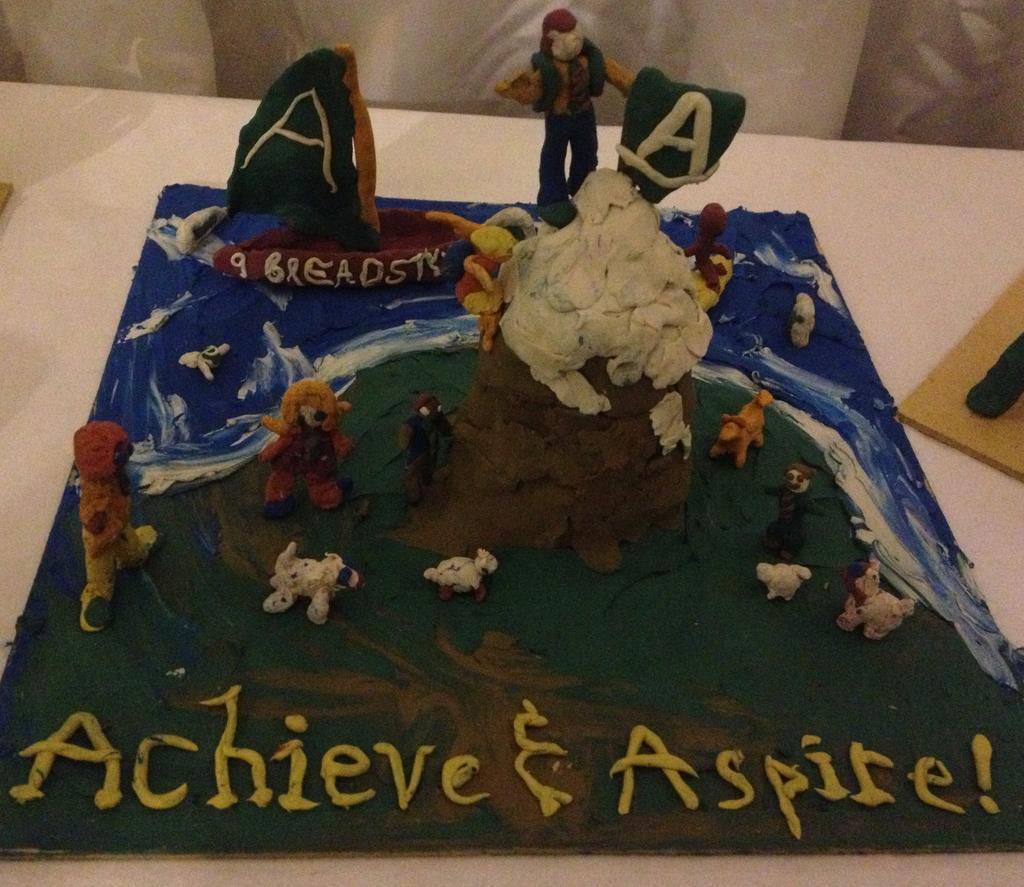Please provide a concise description of this image. In this picture we observe a Clay art made on which Achieve and Aspire is written. 